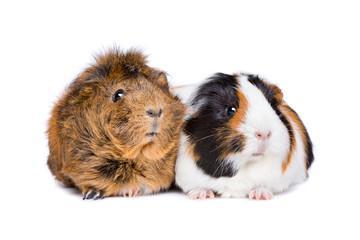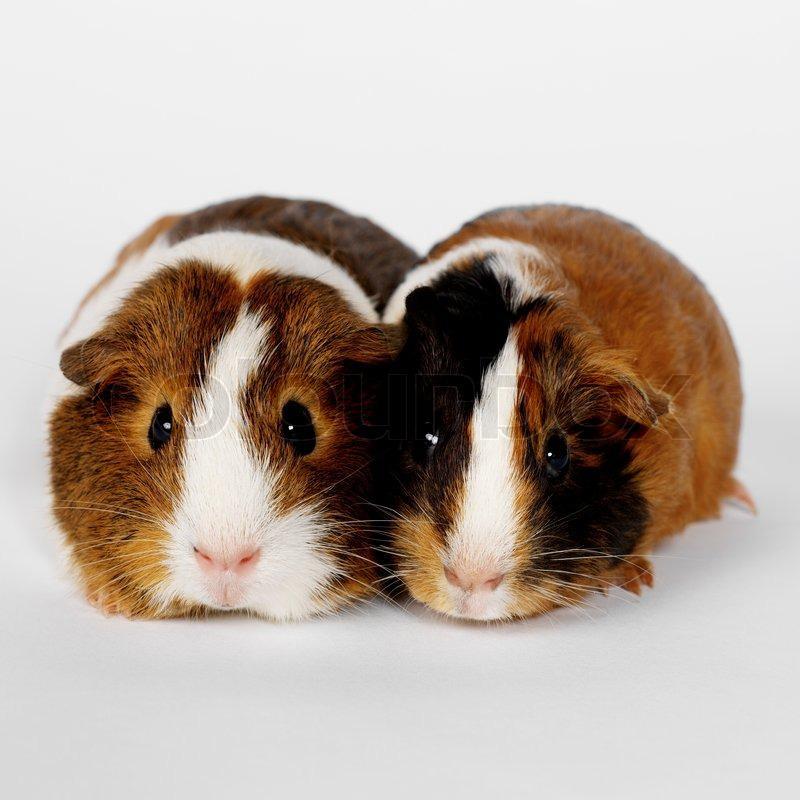The first image is the image on the left, the second image is the image on the right. For the images shown, is this caption "An image features a larger rodent with at least one smaller rodent's head on its back." true? Answer yes or no. No. The first image is the image on the left, the second image is the image on the right. Evaluate the accuracy of this statement regarding the images: "Two rodents are posing side by side.". Is it true? Answer yes or no. Yes. 